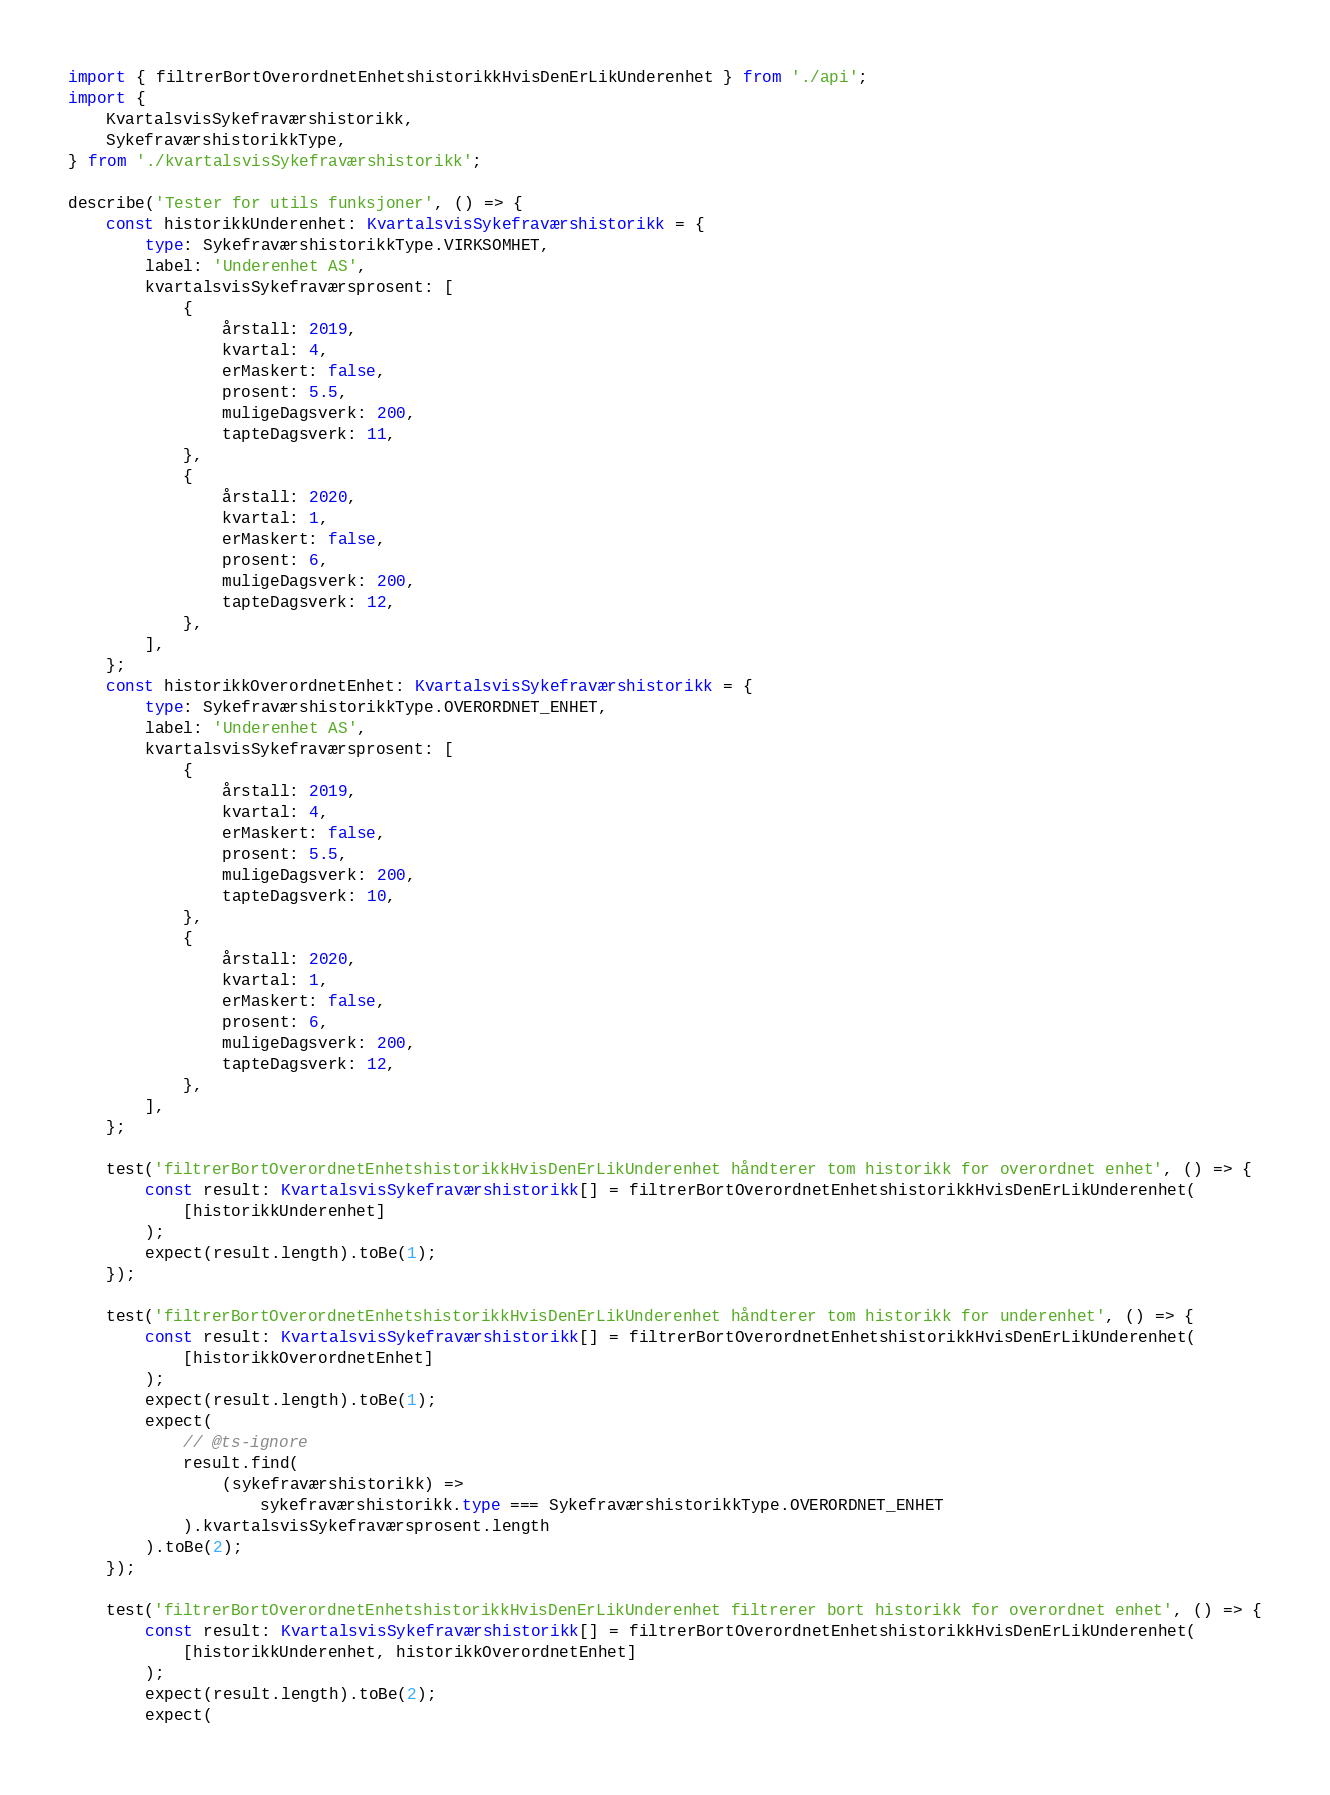<code> <loc_0><loc_0><loc_500><loc_500><_TypeScript_>import { filtrerBortOverordnetEnhetshistorikkHvisDenErLikUnderenhet } from './api';
import {
    KvartalsvisSykefraværshistorikk,
    SykefraværshistorikkType,
} from './kvartalsvisSykefraværshistorikk';

describe('Tester for utils funksjoner', () => {
    const historikkUnderenhet: KvartalsvisSykefraværshistorikk = {
        type: SykefraværshistorikkType.VIRKSOMHET,
        label: 'Underenhet AS',
        kvartalsvisSykefraværsprosent: [
            {
                årstall: 2019,
                kvartal: 4,
                erMaskert: false,
                prosent: 5.5,
                muligeDagsverk: 200,
                tapteDagsverk: 11,
            },
            {
                årstall: 2020,
                kvartal: 1,
                erMaskert: false,
                prosent: 6,
                muligeDagsverk: 200,
                tapteDagsverk: 12,
            },
        ],
    };
    const historikkOverordnetEnhet: KvartalsvisSykefraværshistorikk = {
        type: SykefraværshistorikkType.OVERORDNET_ENHET,
        label: 'Underenhet AS',
        kvartalsvisSykefraværsprosent: [
            {
                årstall: 2019,
                kvartal: 4,
                erMaskert: false,
                prosent: 5.5,
                muligeDagsverk: 200,
                tapteDagsverk: 10,
            },
            {
                årstall: 2020,
                kvartal: 1,
                erMaskert: false,
                prosent: 6,
                muligeDagsverk: 200,
                tapteDagsverk: 12,
            },
        ],
    };

    test('filtrerBortOverordnetEnhetshistorikkHvisDenErLikUnderenhet håndterer tom historikk for overordnet enhet', () => {
        const result: KvartalsvisSykefraværshistorikk[] = filtrerBortOverordnetEnhetshistorikkHvisDenErLikUnderenhet(
            [historikkUnderenhet]
        );
        expect(result.length).toBe(1);
    });

    test('filtrerBortOverordnetEnhetshistorikkHvisDenErLikUnderenhet håndterer tom historikk for underenhet', () => {
        const result: KvartalsvisSykefraværshistorikk[] = filtrerBortOverordnetEnhetshistorikkHvisDenErLikUnderenhet(
            [historikkOverordnetEnhet]
        );
        expect(result.length).toBe(1);
        expect(
            // @ts-ignore
            result.find(
                (sykefraværshistorikk) =>
                    sykefraværshistorikk.type === SykefraværshistorikkType.OVERORDNET_ENHET
            ).kvartalsvisSykefraværsprosent.length
        ).toBe(2);
    });

    test('filtrerBortOverordnetEnhetshistorikkHvisDenErLikUnderenhet filtrerer bort historikk for overordnet enhet', () => {
        const result: KvartalsvisSykefraværshistorikk[] = filtrerBortOverordnetEnhetshistorikkHvisDenErLikUnderenhet(
            [historikkUnderenhet, historikkOverordnetEnhet]
        );
        expect(result.length).toBe(2);
        expect(</code> 